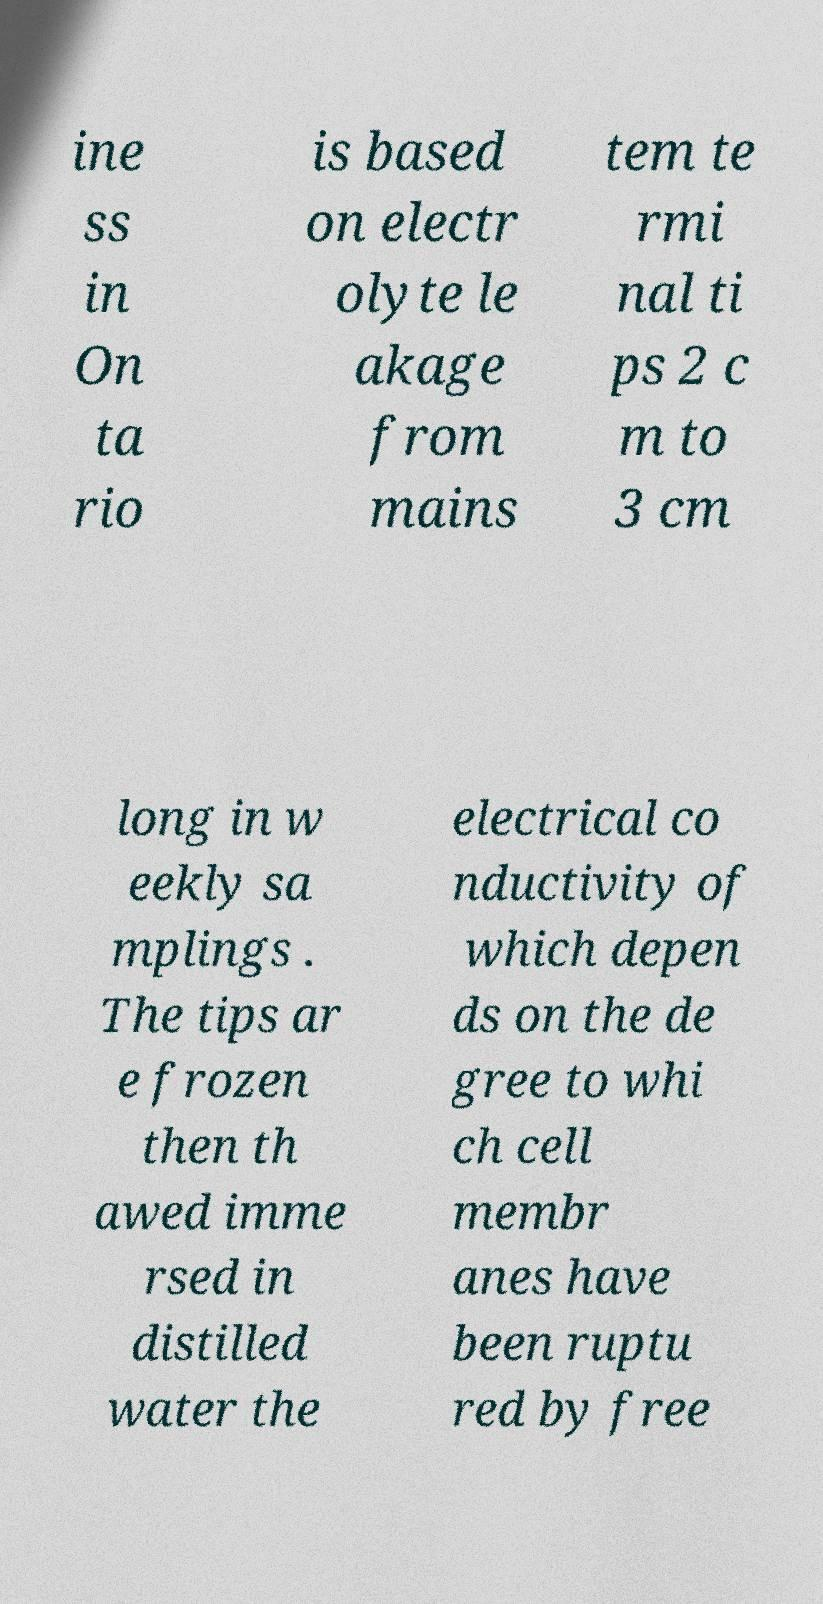I need the written content from this picture converted into text. Can you do that? ine ss in On ta rio is based on electr olyte le akage from mains tem te rmi nal ti ps 2 c m to 3 cm long in w eekly sa mplings . The tips ar e frozen then th awed imme rsed in distilled water the electrical co nductivity of which depen ds on the de gree to whi ch cell membr anes have been ruptu red by free 